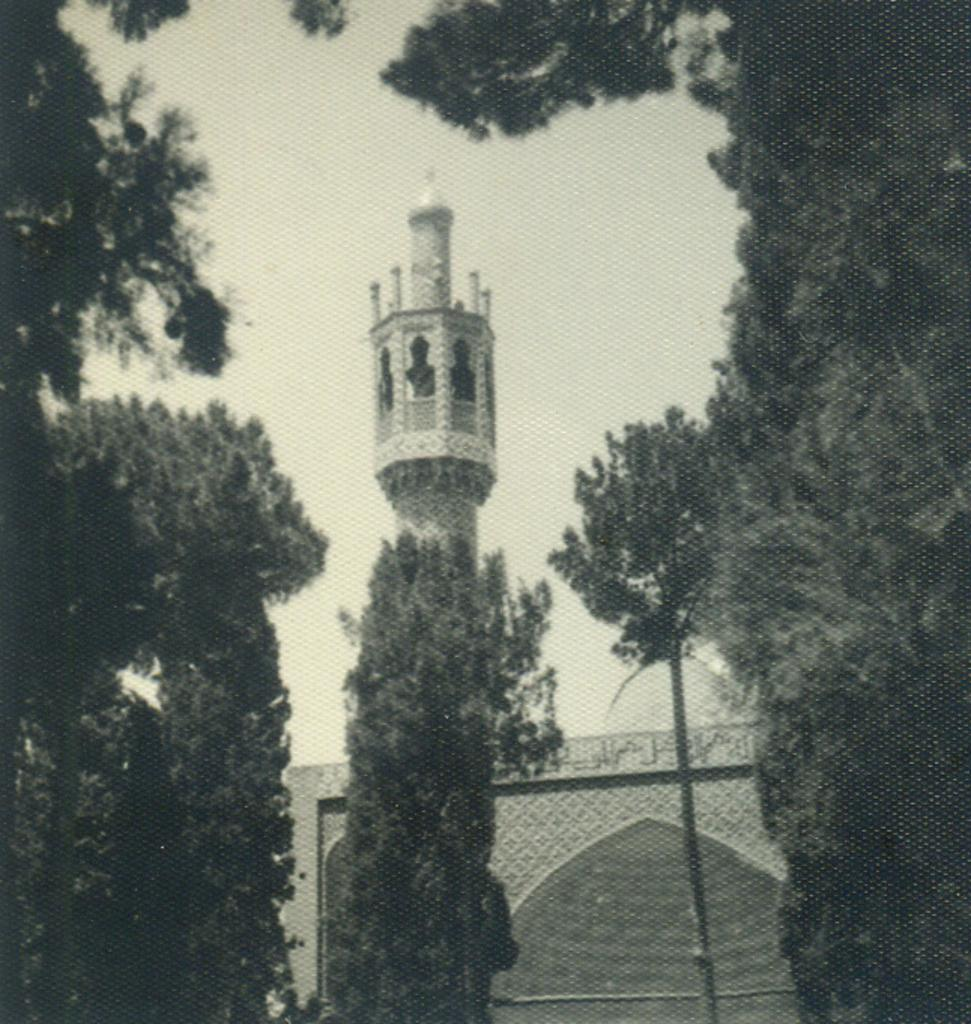What is the color scheme of the image? The image is black and white. What type of natural elements can be seen in the image? There are trees in the image. What man-made structures are present in the image? There is a pole, a building, and a tower in the image. Can you tell me how many people are swimming in the cellar in the image? There is no cellar or swimming activity present in the image. What type of industry is depicted in the image? The image does not depict any specific industry; it features a pole, a building, and a tower. 